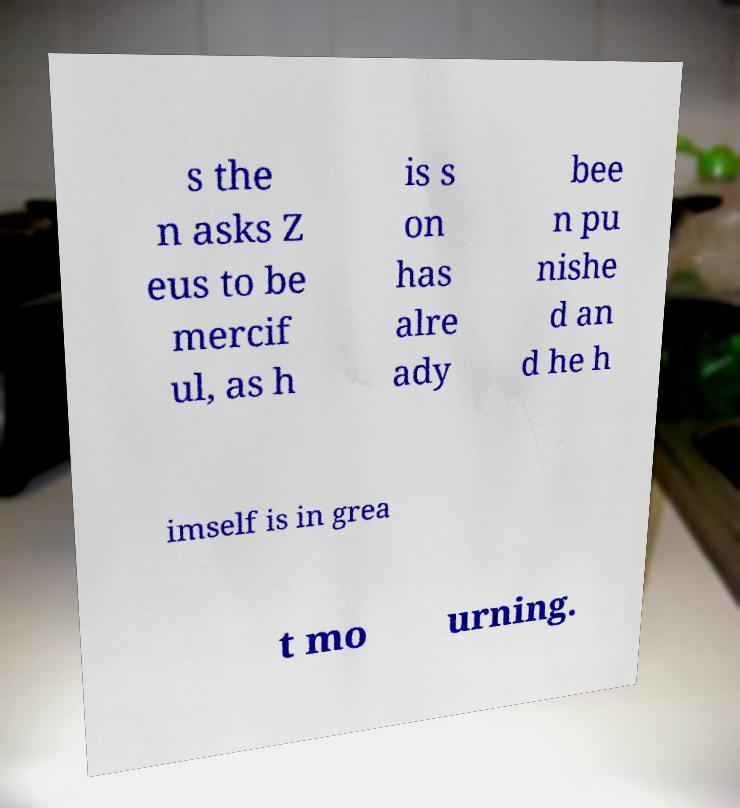I need the written content from this picture converted into text. Can you do that? s the n asks Z eus to be mercif ul, as h is s on has alre ady bee n pu nishe d an d he h imself is in grea t mo urning. 